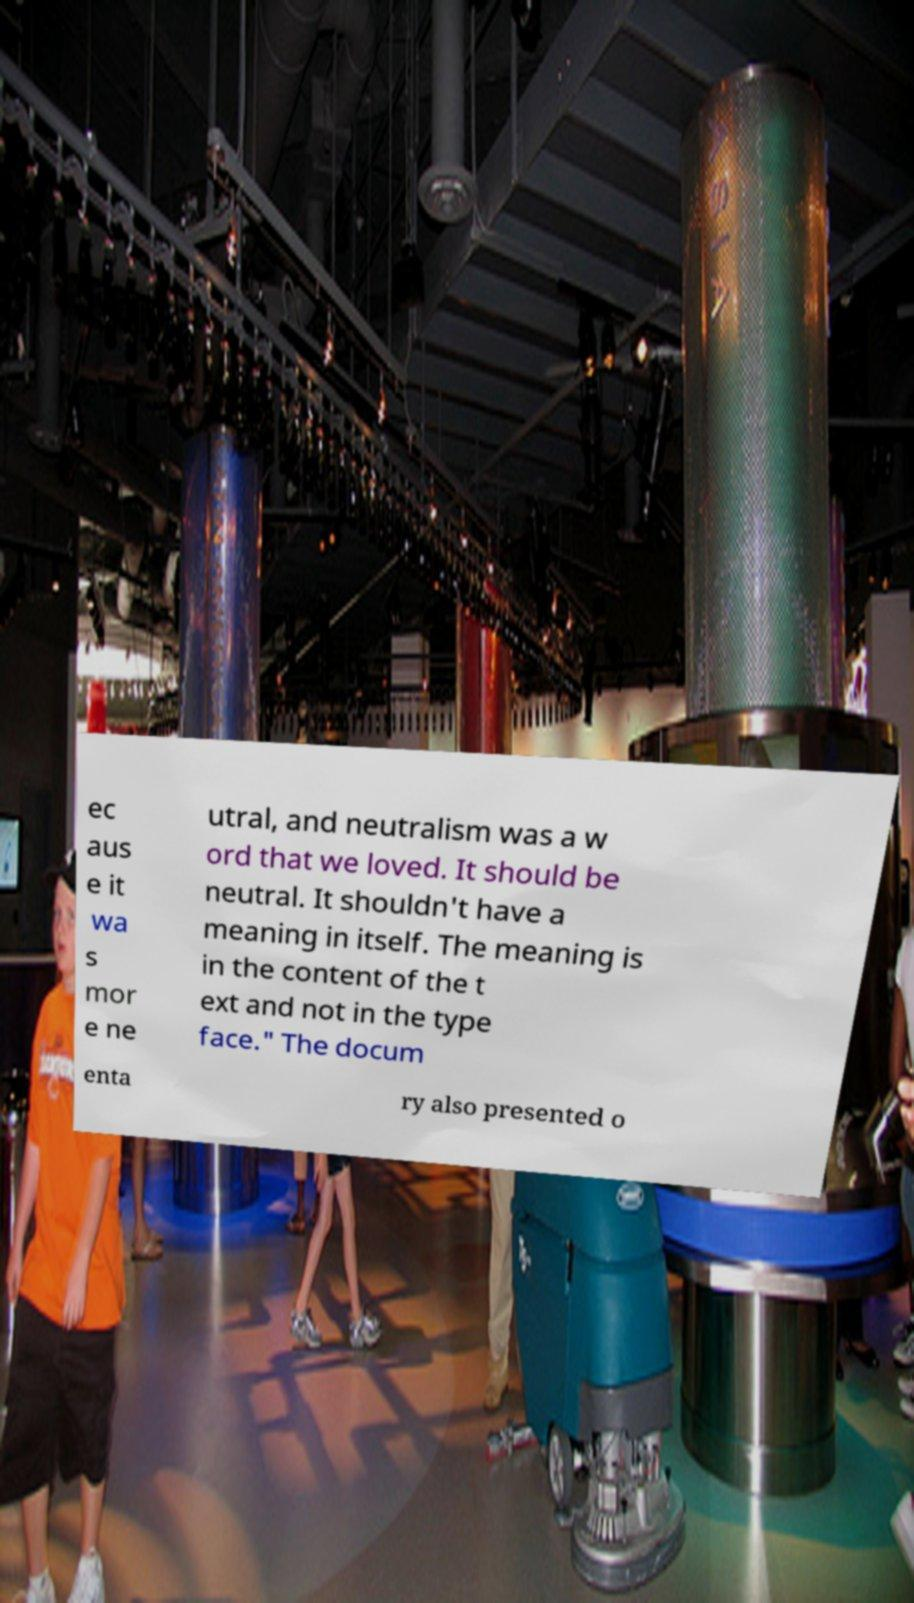Can you accurately transcribe the text from the provided image for me? ec aus e it wa s mor e ne utral, and neutralism was a w ord that we loved. It should be neutral. It shouldn't have a meaning in itself. The meaning is in the content of the t ext and not in the type face." The docum enta ry also presented o 